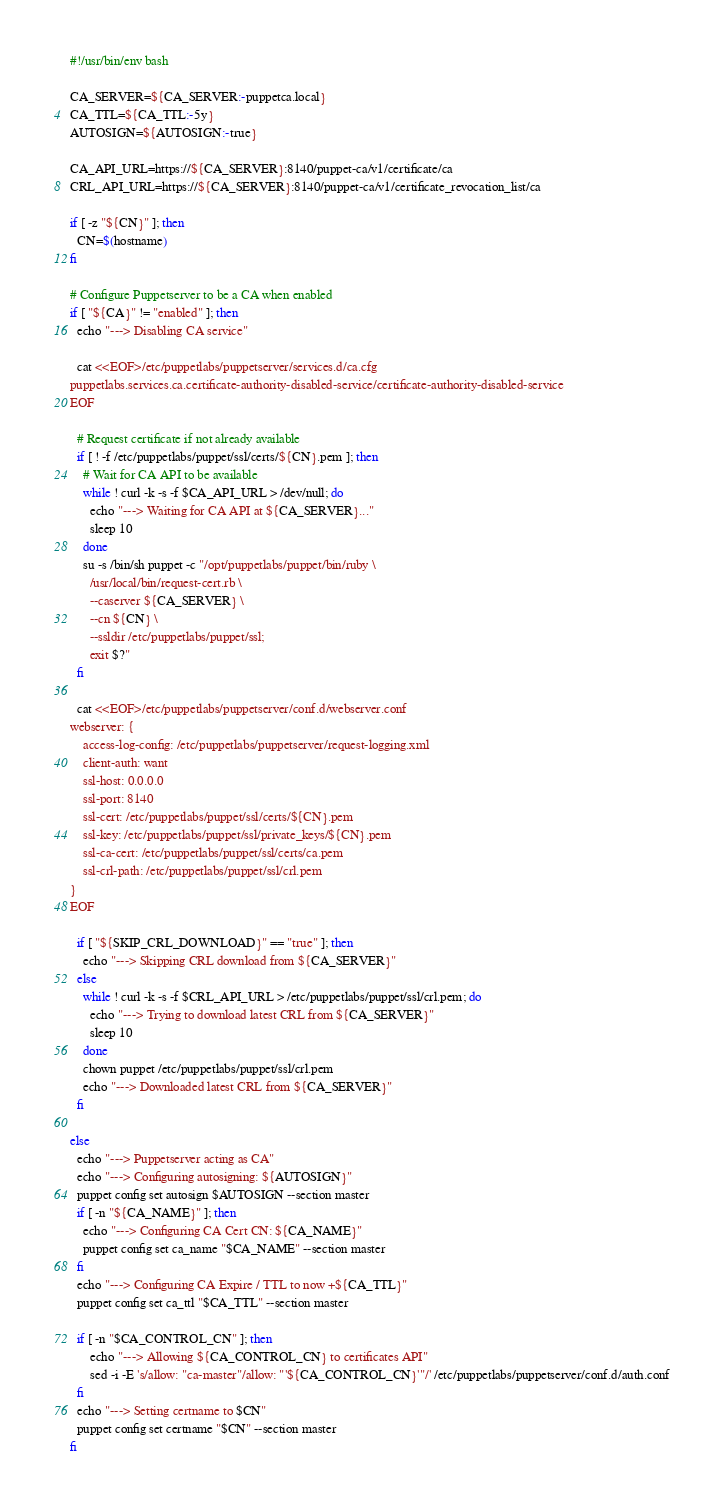Convert code to text. <code><loc_0><loc_0><loc_500><loc_500><_Bash_>#!/usr/bin/env bash

CA_SERVER=${CA_SERVER:-puppetca.local}
CA_TTL=${CA_TTL:-5y}
AUTOSIGN=${AUTOSIGN:-true}

CA_API_URL=https://${CA_SERVER}:8140/puppet-ca/v1/certificate/ca
CRL_API_URL=https://${CA_SERVER}:8140/puppet-ca/v1/certificate_revocation_list/ca

if [ -z "${CN}" ]; then
  CN=$(hostname)
fi

# Configure Puppetserver to be a CA when enabled
if [ "${CA}" != "enabled" ]; then
  echo "---> Disabling CA service"

  cat <<EOF>/etc/puppetlabs/puppetserver/services.d/ca.cfg
puppetlabs.services.ca.certificate-authority-disabled-service/certificate-authority-disabled-service
EOF

  # Request certificate if not already available
  if [ ! -f /etc/puppetlabs/puppet/ssl/certs/${CN}.pem ]; then
    # Wait for CA API to be available
    while ! curl -k -s -f $CA_API_URL > /dev/null; do
      echo "---> Waiting for CA API at ${CA_SERVER}..."
      sleep 10
    done
    su -s /bin/sh puppet -c "/opt/puppetlabs/puppet/bin/ruby \
      /usr/local/bin/request-cert.rb \
      --caserver ${CA_SERVER} \
      --cn ${CN} \
      --ssldir /etc/puppetlabs/puppet/ssl;
      exit $?"
  fi

  cat <<EOF>/etc/puppetlabs/puppetserver/conf.d/webserver.conf
webserver: {
    access-log-config: /etc/puppetlabs/puppetserver/request-logging.xml
    client-auth: want
    ssl-host: 0.0.0.0
    ssl-port: 8140
    ssl-cert: /etc/puppetlabs/puppet/ssl/certs/${CN}.pem
    ssl-key: /etc/puppetlabs/puppet/ssl/private_keys/${CN}.pem
    ssl-ca-cert: /etc/puppetlabs/puppet/ssl/certs/ca.pem
    ssl-crl-path: /etc/puppetlabs/puppet/ssl/crl.pem
}
EOF

  if [ "${SKIP_CRL_DOWNLOAD}" == "true" ]; then
    echo "---> Skipping CRL download from ${CA_SERVER}"
  else
    while ! curl -k -s -f $CRL_API_URL > /etc/puppetlabs/puppet/ssl/crl.pem; do
      echo "---> Trying to download latest CRL from ${CA_SERVER}"
      sleep 10
    done
    chown puppet /etc/puppetlabs/puppet/ssl/crl.pem
    echo "---> Downloaded latest CRL from ${CA_SERVER}"
  fi

else
  echo "---> Puppetserver acting as CA"
  echo "---> Configuring autosigning: ${AUTOSIGN}"
  puppet config set autosign $AUTOSIGN --section master
  if [ -n "${CA_NAME}" ]; then
    echo "---> Configuring CA Cert CN: ${CA_NAME}"
    puppet config set ca_name "$CA_NAME" --section master
  fi
  echo "---> Configuring CA Expire / TTL to now +${CA_TTL}"
  puppet config set ca_ttl "$CA_TTL" --section master

  if [ -n "$CA_CONTROL_CN" ]; then
      echo "---> Allowing ${CA_CONTROL_CN} to certificates API"
      sed -i -E 's/allow: "ca-master"/allow: "'${CA_CONTROL_CN}'"/' /etc/puppetlabs/puppetserver/conf.d/auth.conf
  fi
  echo "---> Setting certname to $CN"
  puppet config set certname "$CN" --section master
fi
</code> 